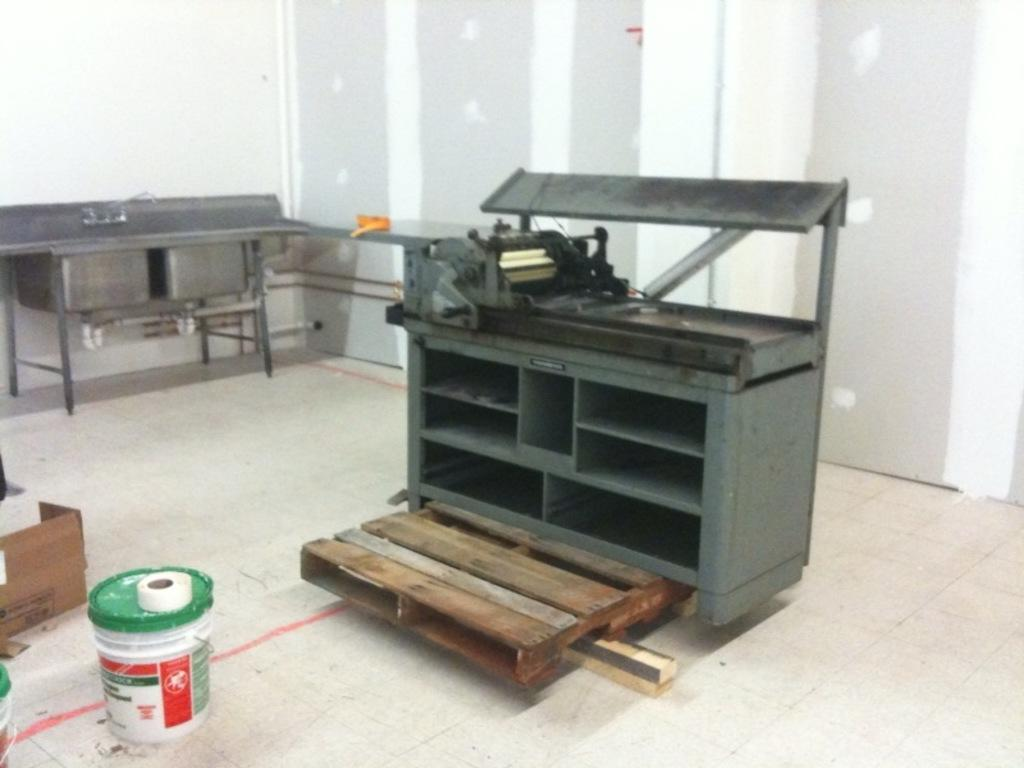What is located in the foreground of the image? In the foreground of the image, there is a cartoon box, plastic boxes, wooden objects, and tables on the floor. What type of objects are made of wood in the image? Wooden objects are present in the foreground of the image. What can be seen in the background of the image? There is a wall visible in the background of the image. Can you describe the setting where the image might have been taken? The image may have been taken in a hall, as suggested by the presence of tables and the wall in the background. Reasoning: Let' Let's think step by step in order to produce the conversation. We start by identifying the main subjects and objects in the image based on the provided facts. We then formulate questions that focus on the location and characteristics of these subjects and objects, ensuring that each question can be answered definitively with the information given. We avoid yes/no questions and ensure that the language is simple and clear. Absurd Question/Answer: How many books are stacked on the tables in the image? There are no books visible in the image; it features a cartoon box, plastic boxes, wooden objects, and tables on the floor. What type of planes can be seen flying in the background of the image? There are no planes visible in the image; it features a wall in the background. How many books are stacked on the tables in the image? There are no books visible in the image; it features a cartoon box, plastic boxes, wooden objects, and tables on the floor. What type of planes can be seen flying in the background of the image? There are no planes visible in the image; it features a wall in the background. 